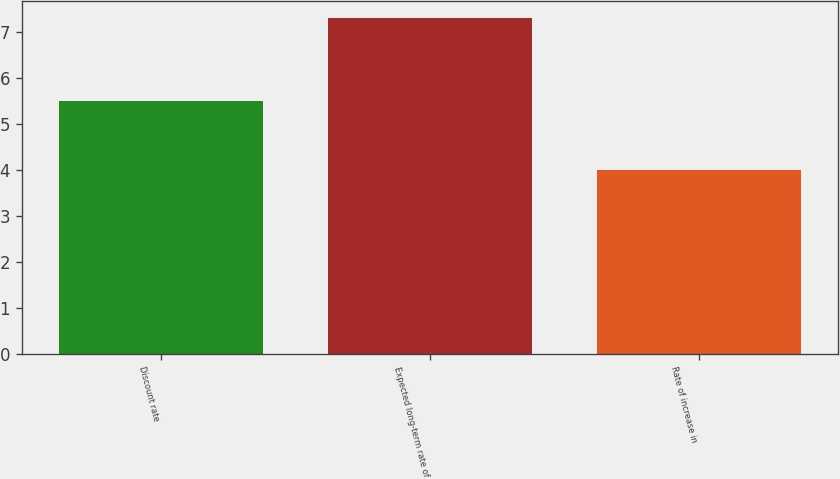Convert chart to OTSL. <chart><loc_0><loc_0><loc_500><loc_500><bar_chart><fcel>Discount rate<fcel>Expected long-term rate of<fcel>Rate of increase in<nl><fcel>5.5<fcel>7.3<fcel>4<nl></chart> 